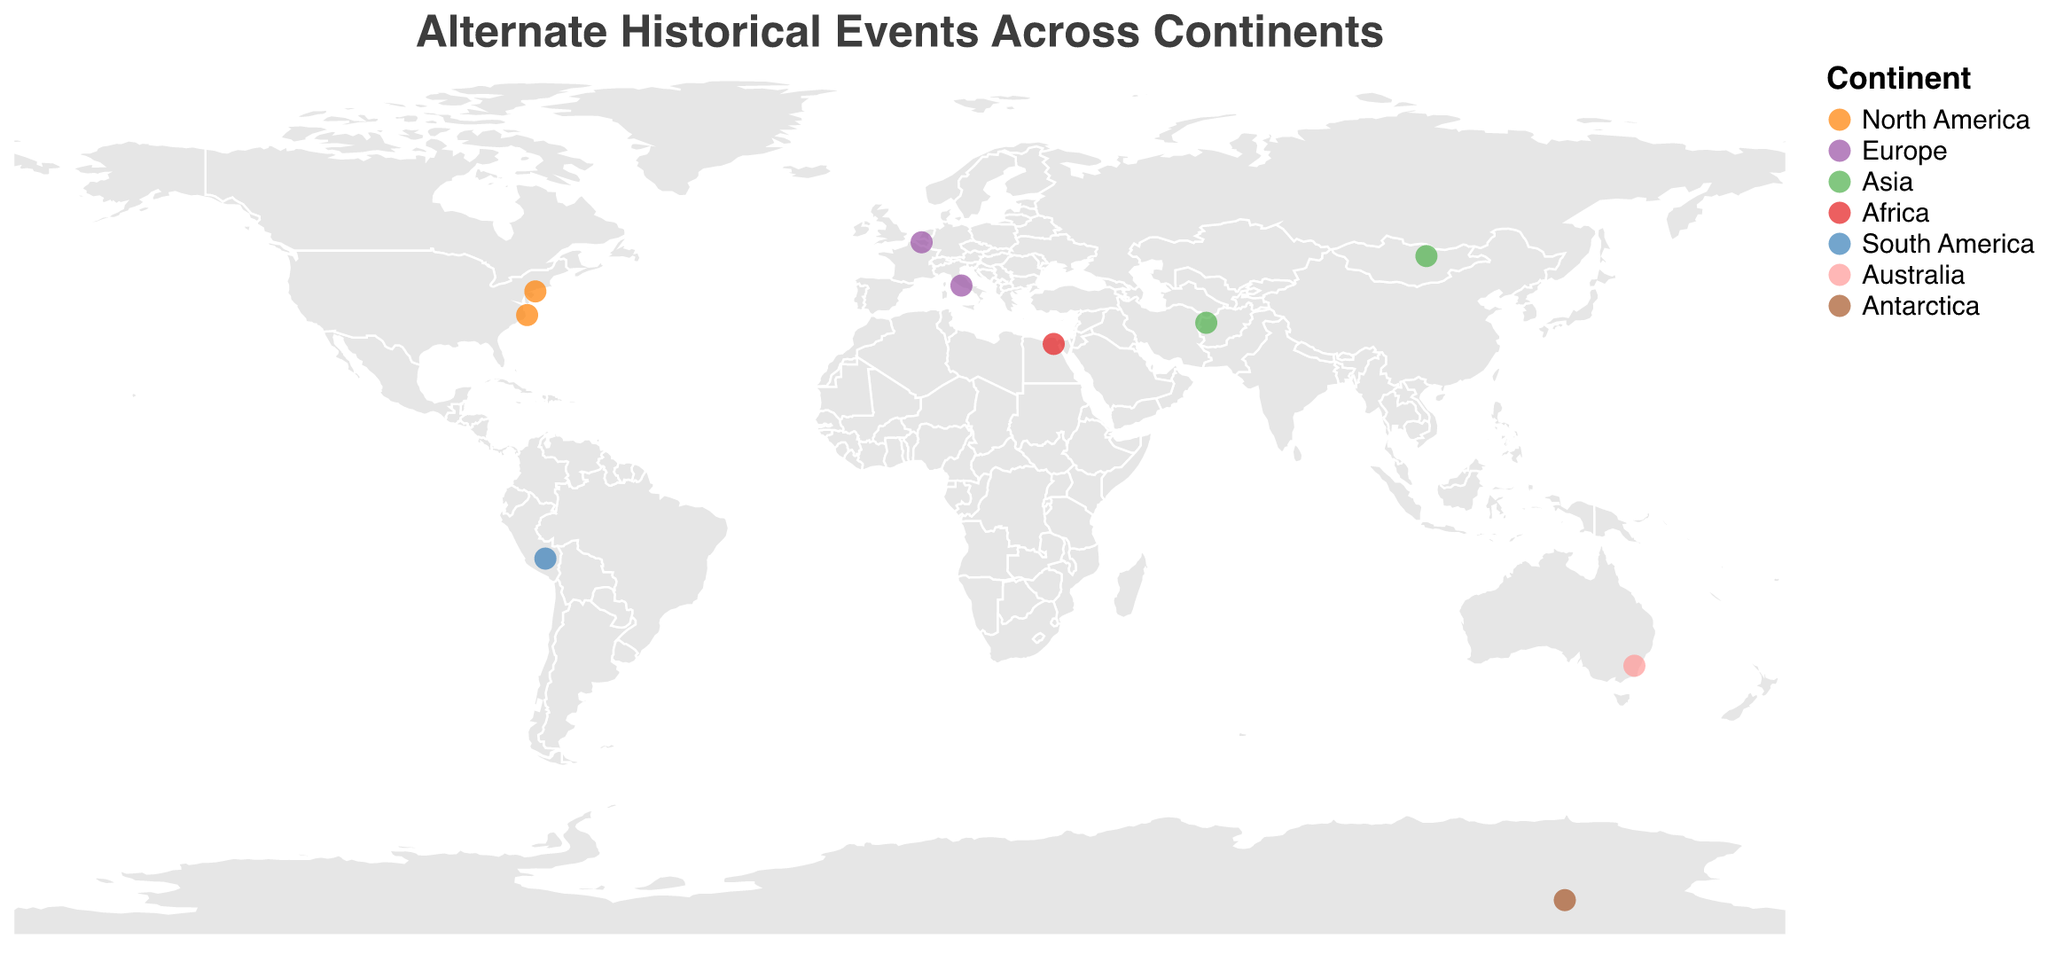What's the title of the plot? The title is usually displayed at the top of the figure, and it describes what the plot is about.
Answer: Alternate Historical Events Across Continents How many alternate historical events are depicted on the map? By counting each distinct data point or circle on the map, you can determine the total number of events.
Answer: 10 Which continent has the event with the latest year? By examining the tooltip information for each event, you can identify the latest year on the plot and check the corresponding continent.
Answer: Europe (Napoleon wins at Waterloo in 1815) Which continents have events occurring before 1000 AD? By inspecting the tooltip information for events and checking the years, you can identify events occurring before 1000 AD and note their continents.
Answer: Asia, Africa, Antarctica What color represents the events in South America? By looking at the legend that maps continents to colors, you can identify the color corresponding to South America.
Answer: Blue What significant event occurred in North America in 1491? By exploring the tooltip information for events in North America, you can find the specific event in 1491.
Answer: Native Americans develop advanced medicine Compare the latitude positions of the events in North America and Australia. Which is further south? By comparing the latitude values in the tooltips for events in North America and Australia, you can determine which event is further south.
Answer: Australia If all events before the year 0 are considered "ancient," how many ancient events are there? By examining the tooltip information and counting the number of events with years before 0, you can find the total number of ancient events.
Answer: 2 Which event is closest to the equator? By checking the latitude values of all events and identifying the one with the smallest absolute latitude, you can find the event closest to the equator.
Answer: Incas repel Spanish conquest (Latitude: -13.5320) What unique event is depicted on the continent of Antarctica? By looking at the concentration of events and their geographical positions, you can identify the unique event on Antarctica from the tooltip.
Answer: Warm climate allows early human settlement 